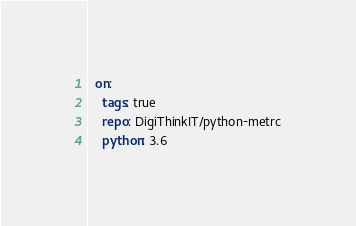<code> <loc_0><loc_0><loc_500><loc_500><_YAML_>  on:
    tags: true
    repo: DigiThinkIT/python-metrc
    python: 3.6
</code> 